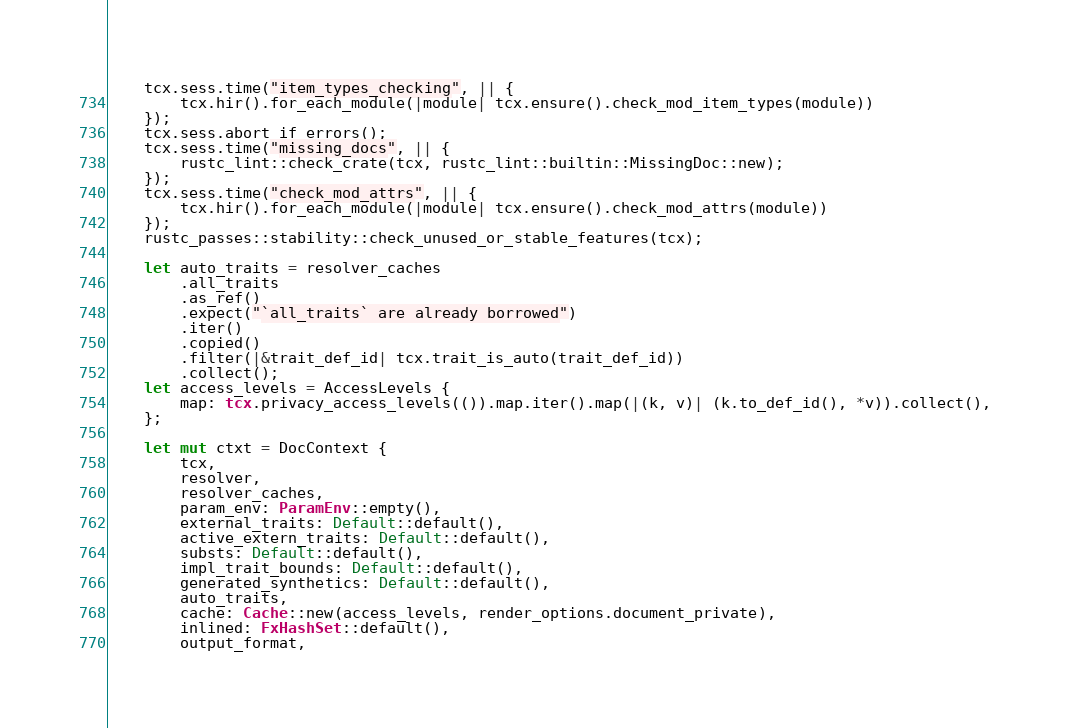Convert code to text. <code><loc_0><loc_0><loc_500><loc_500><_Rust_>    tcx.sess.time("item_types_checking", || {
        tcx.hir().for_each_module(|module| tcx.ensure().check_mod_item_types(module))
    });
    tcx.sess.abort_if_errors();
    tcx.sess.time("missing_docs", || {
        rustc_lint::check_crate(tcx, rustc_lint::builtin::MissingDoc::new);
    });
    tcx.sess.time("check_mod_attrs", || {
        tcx.hir().for_each_module(|module| tcx.ensure().check_mod_attrs(module))
    });
    rustc_passes::stability::check_unused_or_stable_features(tcx);

    let auto_traits = resolver_caches
        .all_traits
        .as_ref()
        .expect("`all_traits` are already borrowed")
        .iter()
        .copied()
        .filter(|&trait_def_id| tcx.trait_is_auto(trait_def_id))
        .collect();
    let access_levels = AccessLevels {
        map: tcx.privacy_access_levels(()).map.iter().map(|(k, v)| (k.to_def_id(), *v)).collect(),
    };

    let mut ctxt = DocContext {
        tcx,
        resolver,
        resolver_caches,
        param_env: ParamEnv::empty(),
        external_traits: Default::default(),
        active_extern_traits: Default::default(),
        substs: Default::default(),
        impl_trait_bounds: Default::default(),
        generated_synthetics: Default::default(),
        auto_traits,
        cache: Cache::new(access_levels, render_options.document_private),
        inlined: FxHashSet::default(),
        output_format,</code> 